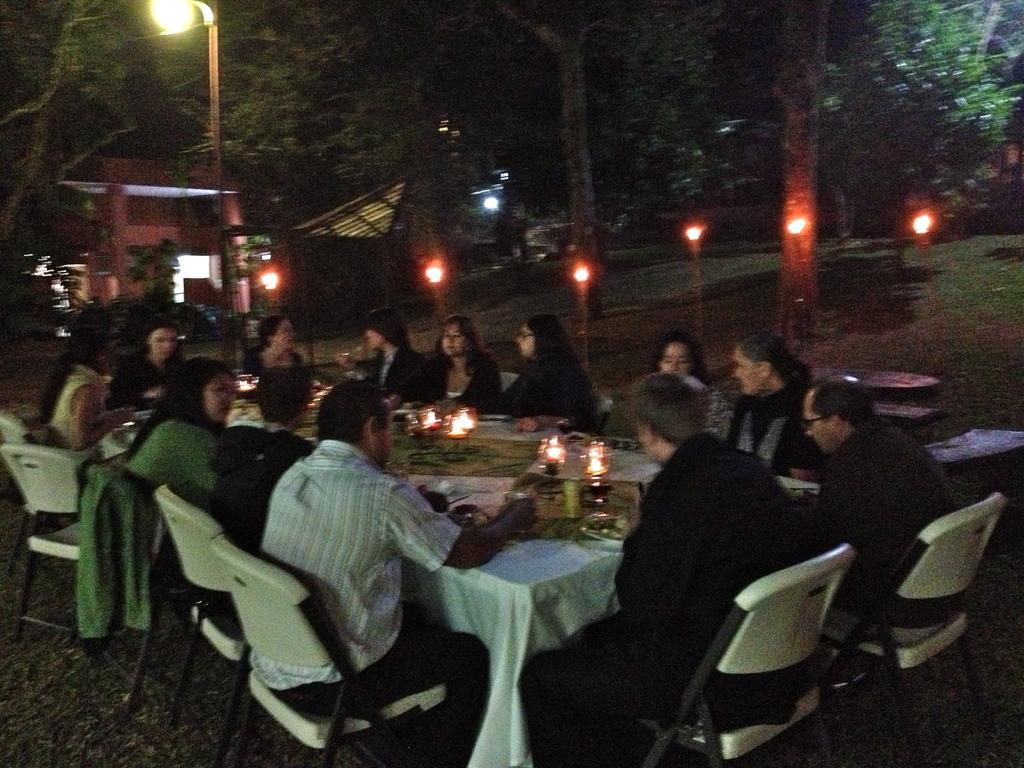What is the main piece of furniture in the image? There is a table in the image. What is placed on the table? Candles are placed on the table. How many chairs are around the table? Chairs are present around the table. What are the people on the chairs doing? People are seated on the chairs. What can be seen in the background of the image? Trees and lights are visible in the background. What time of day is the scene taking place? The scene takes place during nighttime. How does the heat affect the candles on the table? There is no mention of heat in the image, so it cannot be determined how it affects the candles. 